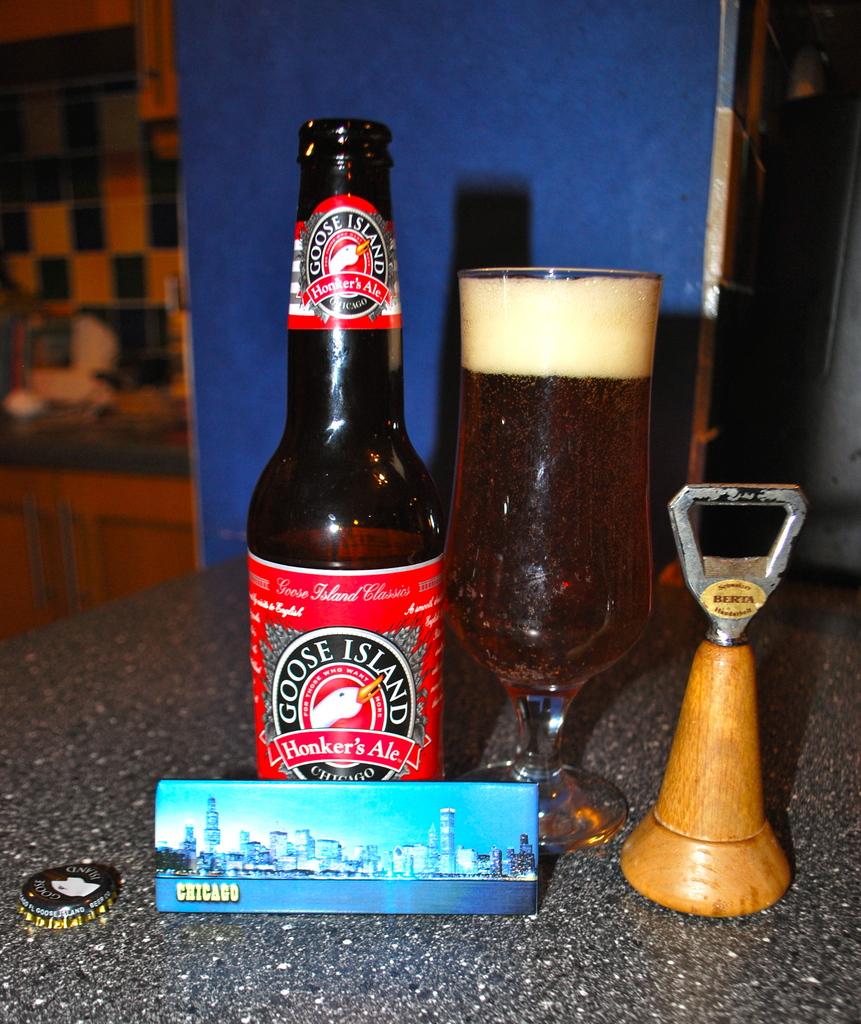What is the city name in the photo?
Make the answer very short. Chicago. 